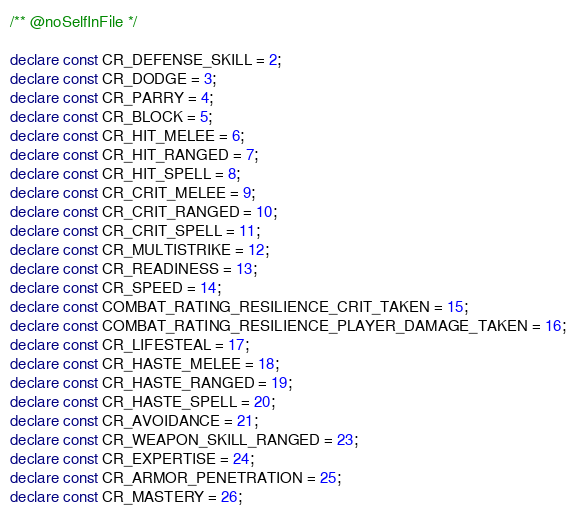<code> <loc_0><loc_0><loc_500><loc_500><_TypeScript_>/** @noSelfInFile */

declare const CR_DEFENSE_SKILL = 2;
declare const CR_DODGE = 3;
declare const CR_PARRY = 4;
declare const CR_BLOCK = 5;
declare const CR_HIT_MELEE = 6;
declare const CR_HIT_RANGED = 7;
declare const CR_HIT_SPELL = 8;
declare const CR_CRIT_MELEE = 9;
declare const CR_CRIT_RANGED = 10;
declare const CR_CRIT_SPELL = 11;
declare const CR_MULTISTRIKE = 12;
declare const CR_READINESS = 13;
declare const CR_SPEED = 14;
declare const COMBAT_RATING_RESILIENCE_CRIT_TAKEN = 15;
declare const COMBAT_RATING_RESILIENCE_PLAYER_DAMAGE_TAKEN = 16;
declare const CR_LIFESTEAL = 17;
declare const CR_HASTE_MELEE = 18;
declare const CR_HASTE_RANGED = 19;
declare const CR_HASTE_SPELL = 20;
declare const CR_AVOIDANCE = 21;
declare const CR_WEAPON_SKILL_RANGED = 23;
declare const CR_EXPERTISE = 24;
declare const CR_ARMOR_PENETRATION = 25;
declare const CR_MASTERY = 26;</code> 